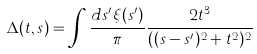<formula> <loc_0><loc_0><loc_500><loc_500>\Delta ( t , s ) = \int \frac { d s ^ { \prime } \xi ( s ^ { \prime } ) } { \pi } \frac { 2 t ^ { 3 } } { ( ( s - s ^ { \prime } ) ^ { 2 } + t ^ { 2 } ) ^ { 2 } }</formula> 